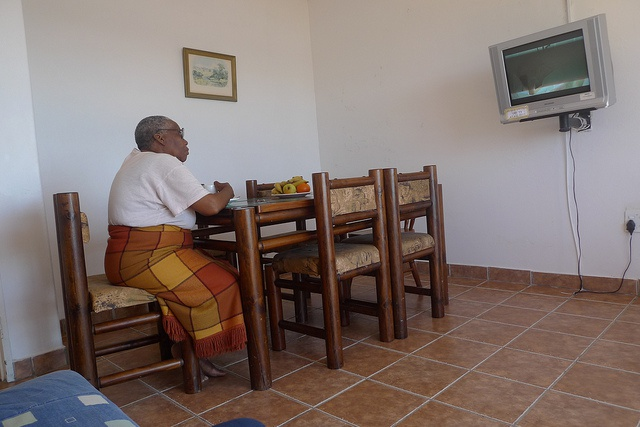Describe the objects in this image and their specific colors. I can see people in darkgray, maroon, olive, and black tones, chair in darkgray, black, maroon, and gray tones, chair in darkgray, black, maroon, and gray tones, tv in darkgray, gray, and black tones, and dining table in darkgray, black, maroon, and gray tones in this image. 